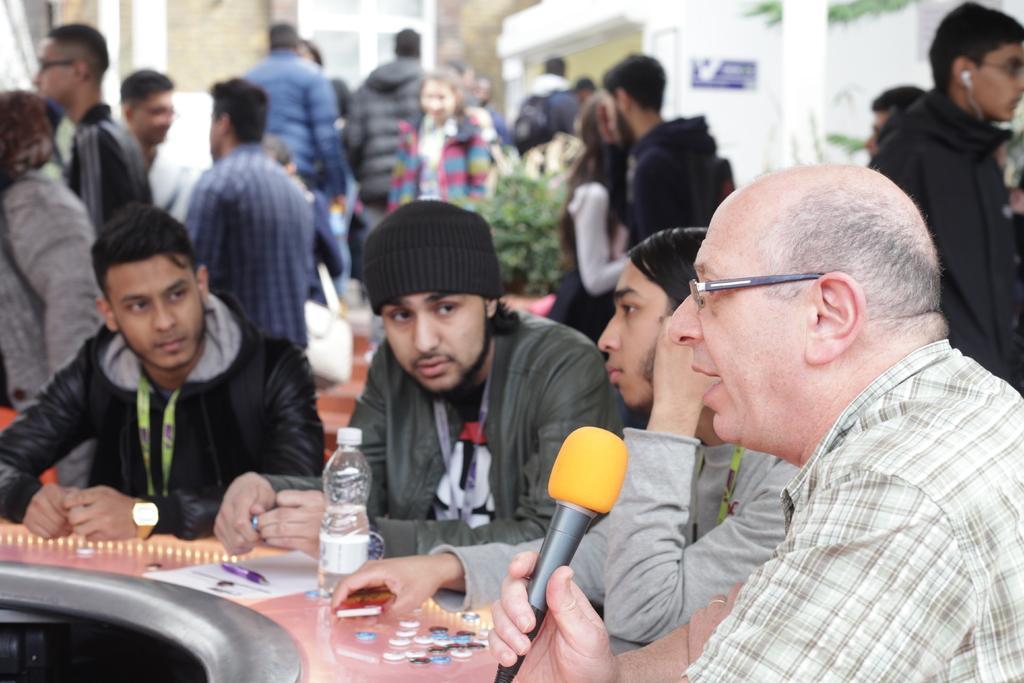Can you describe this image briefly? On the right there is a man who is wearing spectacle and shirt. He is holding a mic, beside him we can see three persons sitting near to the table. On the table we can see a water bottle, pen, coins, paper and other objects. In the background we can see group of persons standing near to the plants. On the top there is a door. On the top right we can see a tree. On the left there is a woman who is wearing jacket and standing near to the men. 